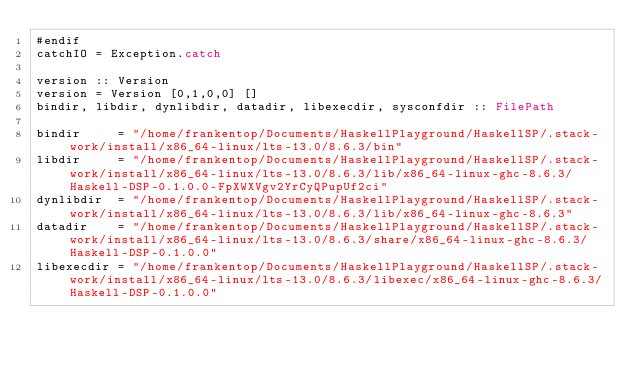<code> <loc_0><loc_0><loc_500><loc_500><_Haskell_>#endif
catchIO = Exception.catch

version :: Version
version = Version [0,1,0,0] []
bindir, libdir, dynlibdir, datadir, libexecdir, sysconfdir :: FilePath

bindir     = "/home/frankentop/Documents/HaskellPlayground/HaskellSP/.stack-work/install/x86_64-linux/lts-13.0/8.6.3/bin"
libdir     = "/home/frankentop/Documents/HaskellPlayground/HaskellSP/.stack-work/install/x86_64-linux/lts-13.0/8.6.3/lib/x86_64-linux-ghc-8.6.3/Haskell-DSP-0.1.0.0-FpXWXVgv2YrCyQPupUf2ci"
dynlibdir  = "/home/frankentop/Documents/HaskellPlayground/HaskellSP/.stack-work/install/x86_64-linux/lts-13.0/8.6.3/lib/x86_64-linux-ghc-8.6.3"
datadir    = "/home/frankentop/Documents/HaskellPlayground/HaskellSP/.stack-work/install/x86_64-linux/lts-13.0/8.6.3/share/x86_64-linux-ghc-8.6.3/Haskell-DSP-0.1.0.0"
libexecdir = "/home/frankentop/Documents/HaskellPlayground/HaskellSP/.stack-work/install/x86_64-linux/lts-13.0/8.6.3/libexec/x86_64-linux-ghc-8.6.3/Haskell-DSP-0.1.0.0"</code> 